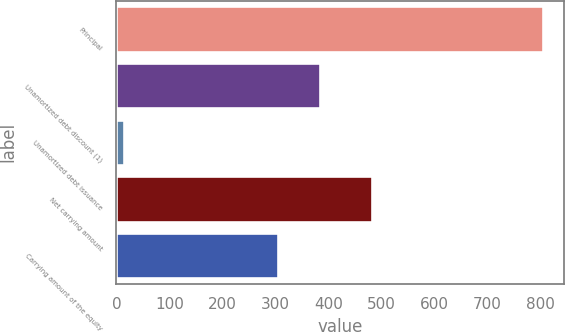Convert chart to OTSL. <chart><loc_0><loc_0><loc_500><loc_500><bar_chart><fcel>Principal<fcel>Unamortized debt discount (1)<fcel>Unamortized debt issuance<fcel>Net carrying amount<fcel>Carrying amount of the equity<nl><fcel>805<fcel>384.1<fcel>14<fcel>483<fcel>305<nl></chart> 